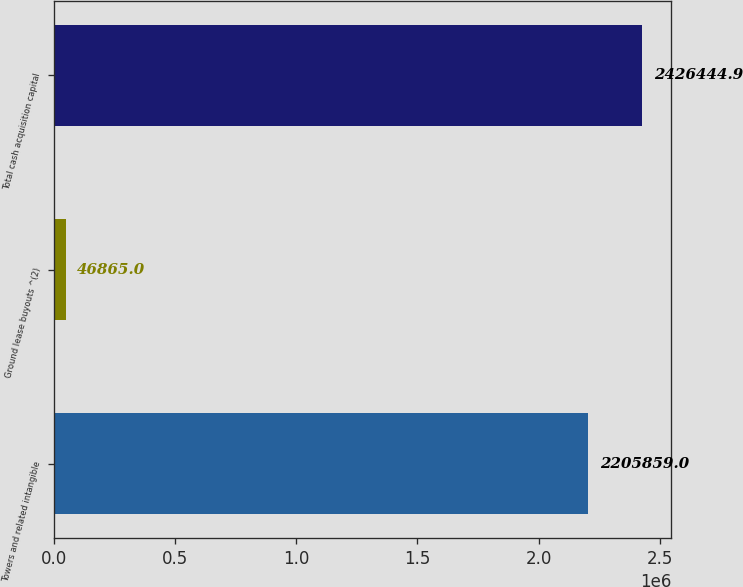<chart> <loc_0><loc_0><loc_500><loc_500><bar_chart><fcel>Towers and related intangible<fcel>Ground lease buyouts ^(2)<fcel>Total cash acquisition capital<nl><fcel>2.20586e+06<fcel>46865<fcel>2.42644e+06<nl></chart> 